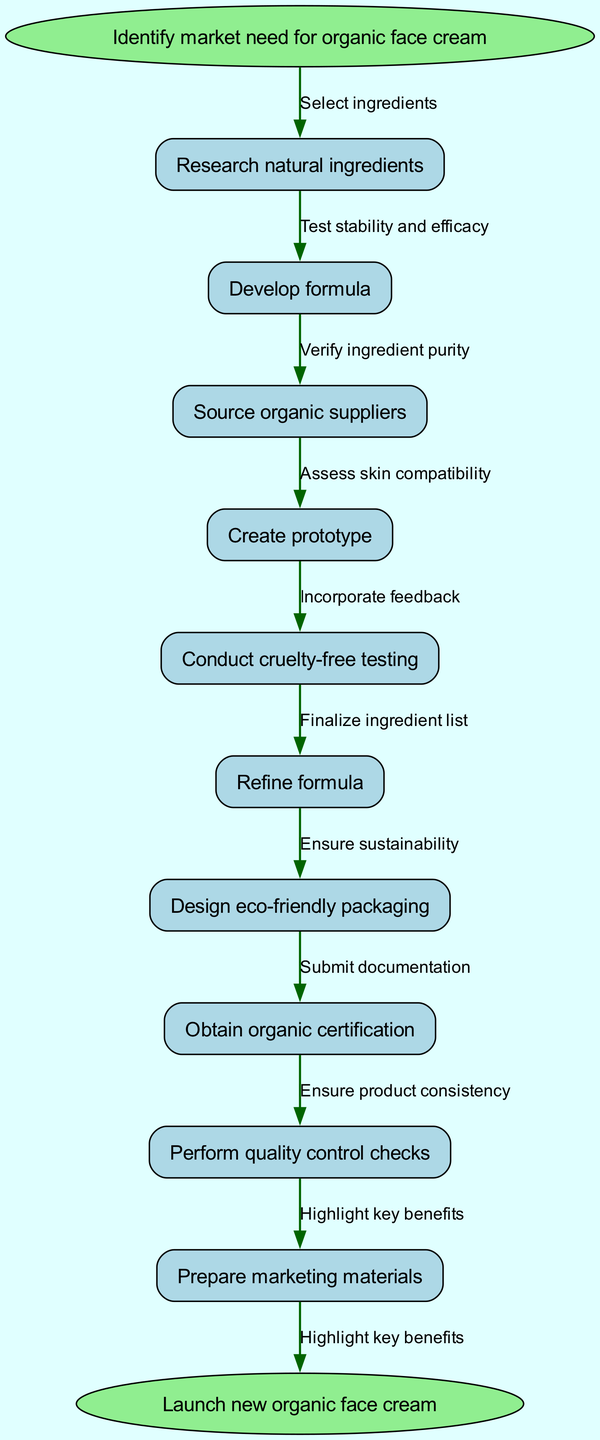What is the starting point of the product development process? The diagram begins with the node labeled "Identify market need for organic face cream," which represents the initial step in the process.
Answer: Identify market need for organic face cream What is the final step indicated in the diagram? The diagram concludes with the node labeled "Launch new organic face cream," marking the end of the product development process.
Answer: Launch new organic face cream How many nodes are present in the diagram? There are a total of 11 nodes, comprising 1 start node, 10 process nodes, and 1 end node.
Answer: 11 What is the fourth node in the process? Referring to the sequence of nodes, the fourth node is "Create prototype," which follows the previous steps.
Answer: Create prototype What connects "Research natural ingredients" to "Develop formula"? The edge connecting these two nodes is represented by the label "Select ingredients," indicating the action taken between these steps.
Answer: Select ingredients How many edges are shown in the diagram? The diagram contains 10 edges that connect the 11 nodes, illustrating the flow from start to end.
Answer: 10 Which step immediately follows "Conduct cruelty-free testing"? The next step after "Conduct cruelty-free testing" is "Refine formula," indicating that adjustments are made based on testing results.
Answer: Refine formula What action is taken after "Source organic suppliers"? The action directly following "Source organic suppliers" is "Create prototype," showing the progression to product creation.
Answer: Create prototype What is the purpose of obtaining organic certification in this process? In this flow, obtaining organic certification is a critical step that ensures the final product meets organic standards, thus confirming its quality and compliance.
Answer: Ensure product meets organic standards 